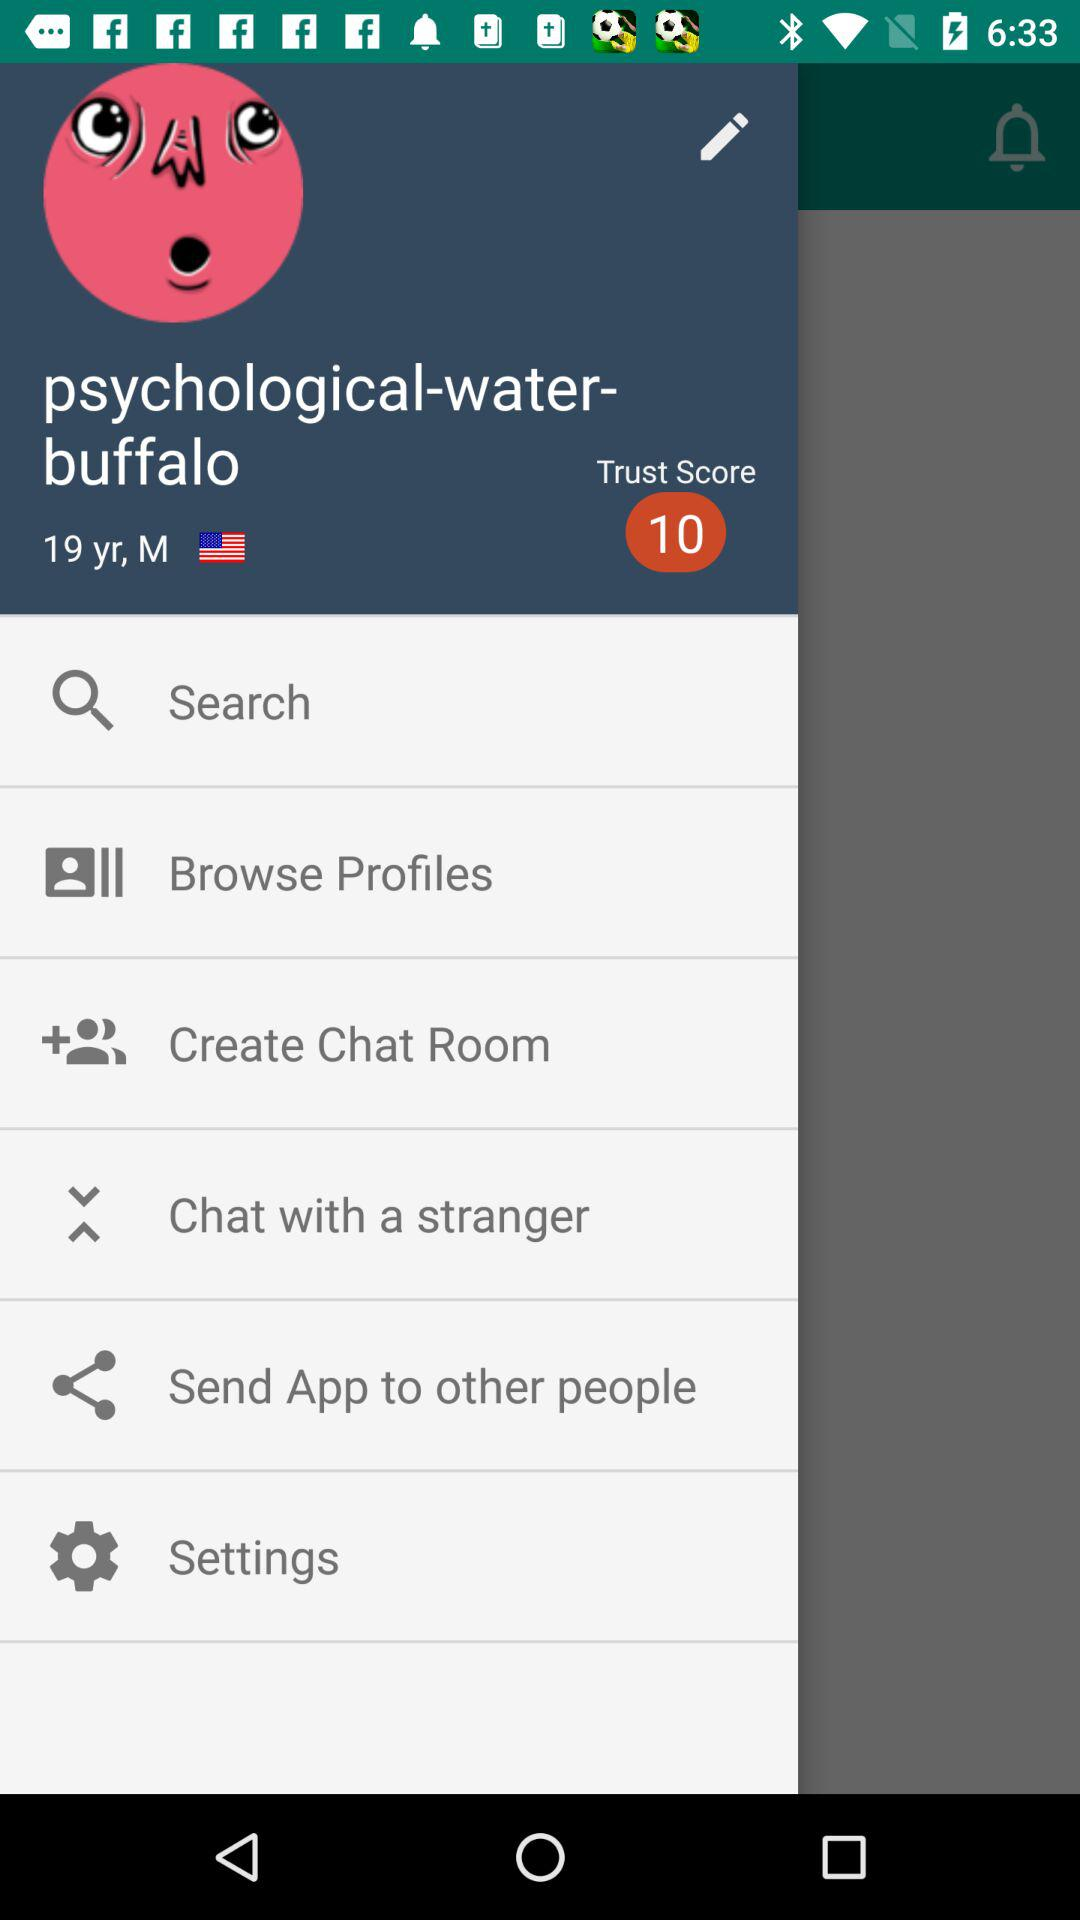What is the mentioned age? The mentioned age is 17 years. 